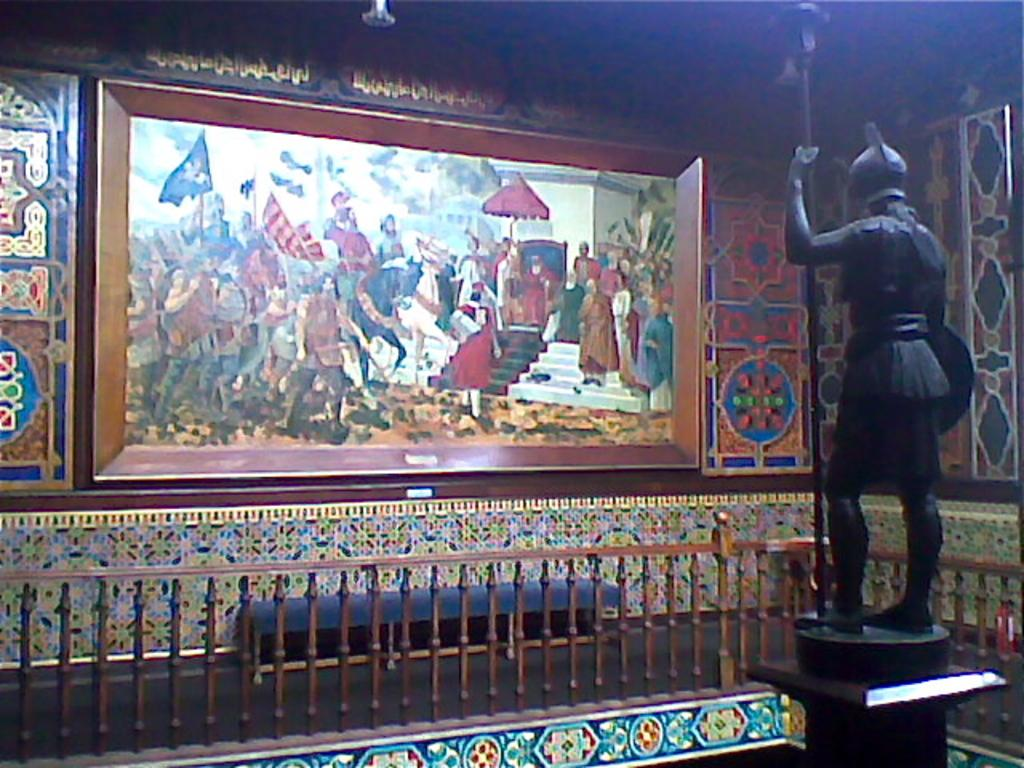What type of establishment is depicted in the image? There is a museum in the image. What type of artwork can be seen in the image? There is a painting in the image. What other type of artwork is present in the image? There is a sculpture in the image. What type of barrier is visible in the image? There is a fencing in the image. Can you tell me how many pigs are rolling around in the image? There are no pigs present in the image, and therefore no rolling activity can be observed. 